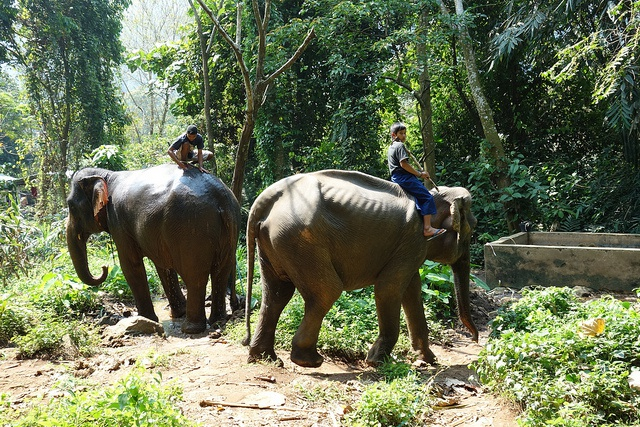Describe the objects in this image and their specific colors. I can see elephant in darkgreen, black, ivory, and gray tones, elephant in darkgreen, black, white, gray, and darkgray tones, people in darkgreen, black, navy, maroon, and gray tones, and people in darkgreen, black, maroon, and gray tones in this image. 